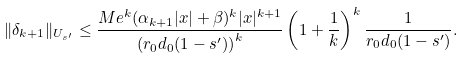<formula> <loc_0><loc_0><loc_500><loc_500>\| \delta _ { k + 1 } \| _ { U _ { s ^ { \prime } } } \leq \frac { M e ^ { k } ( \alpha _ { k + 1 } | x | + \beta ) ^ { k } | x | ^ { k + 1 } } { \left ( r _ { 0 } d _ { 0 } ( 1 - s ^ { \prime } ) \right ) ^ { k } } \left ( 1 + \frac { 1 } { k } \right ) ^ { k } \frac { 1 } { r _ { 0 } d _ { 0 } ( 1 - s ^ { \prime } ) } .</formula> 